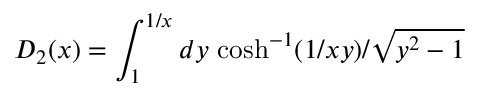<formula> <loc_0><loc_0><loc_500><loc_500>D _ { 2 } ( x ) = \int _ { 1 } ^ { 1 / x } d y \, \cosh ^ { - 1 } ( 1 / x y ) / \sqrt { y ^ { 2 } - 1 }</formula> 